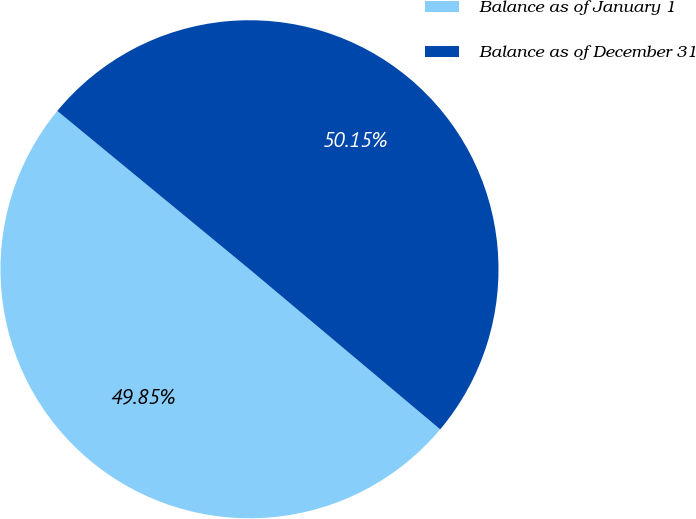Convert chart to OTSL. <chart><loc_0><loc_0><loc_500><loc_500><pie_chart><fcel>Balance as of January 1<fcel>Balance as of December 31<nl><fcel>49.85%<fcel>50.15%<nl></chart> 